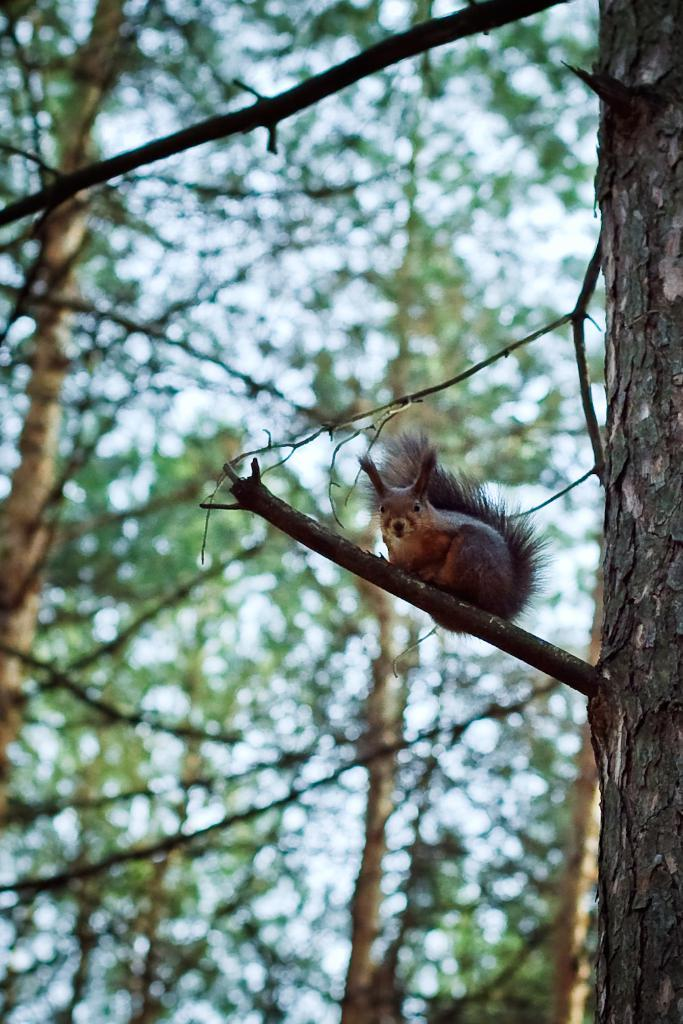What type of vegetation can be seen in the image? There are trees in the image. What animal is present in the image? There is a squirrel in the image. What type of brass instrument is the squirrel playing in the image? There is no brass instrument present in the image; it features a squirrel and trees. How does the heat affect the squirrel's behavior in the image? There is no information about heat or the squirrel's behavior in the image. 